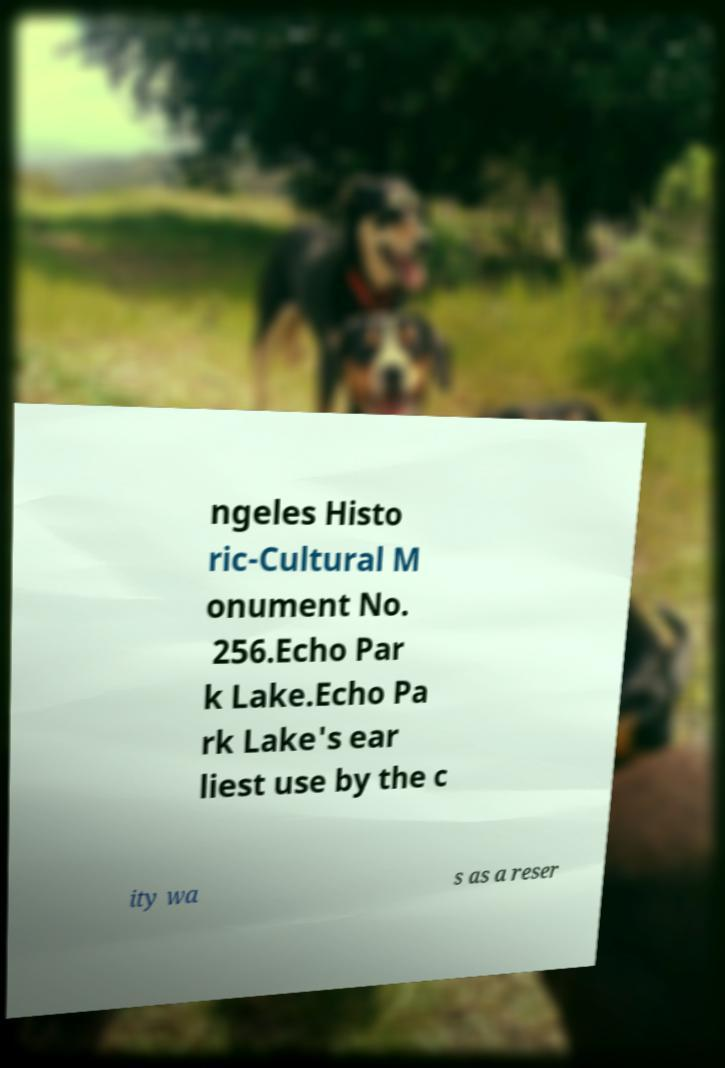Can you accurately transcribe the text from the provided image for me? ngeles Histo ric-Cultural M onument No. 256.Echo Par k Lake.Echo Pa rk Lake's ear liest use by the c ity wa s as a reser 